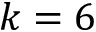<formula> <loc_0><loc_0><loc_500><loc_500>k = 6</formula> 